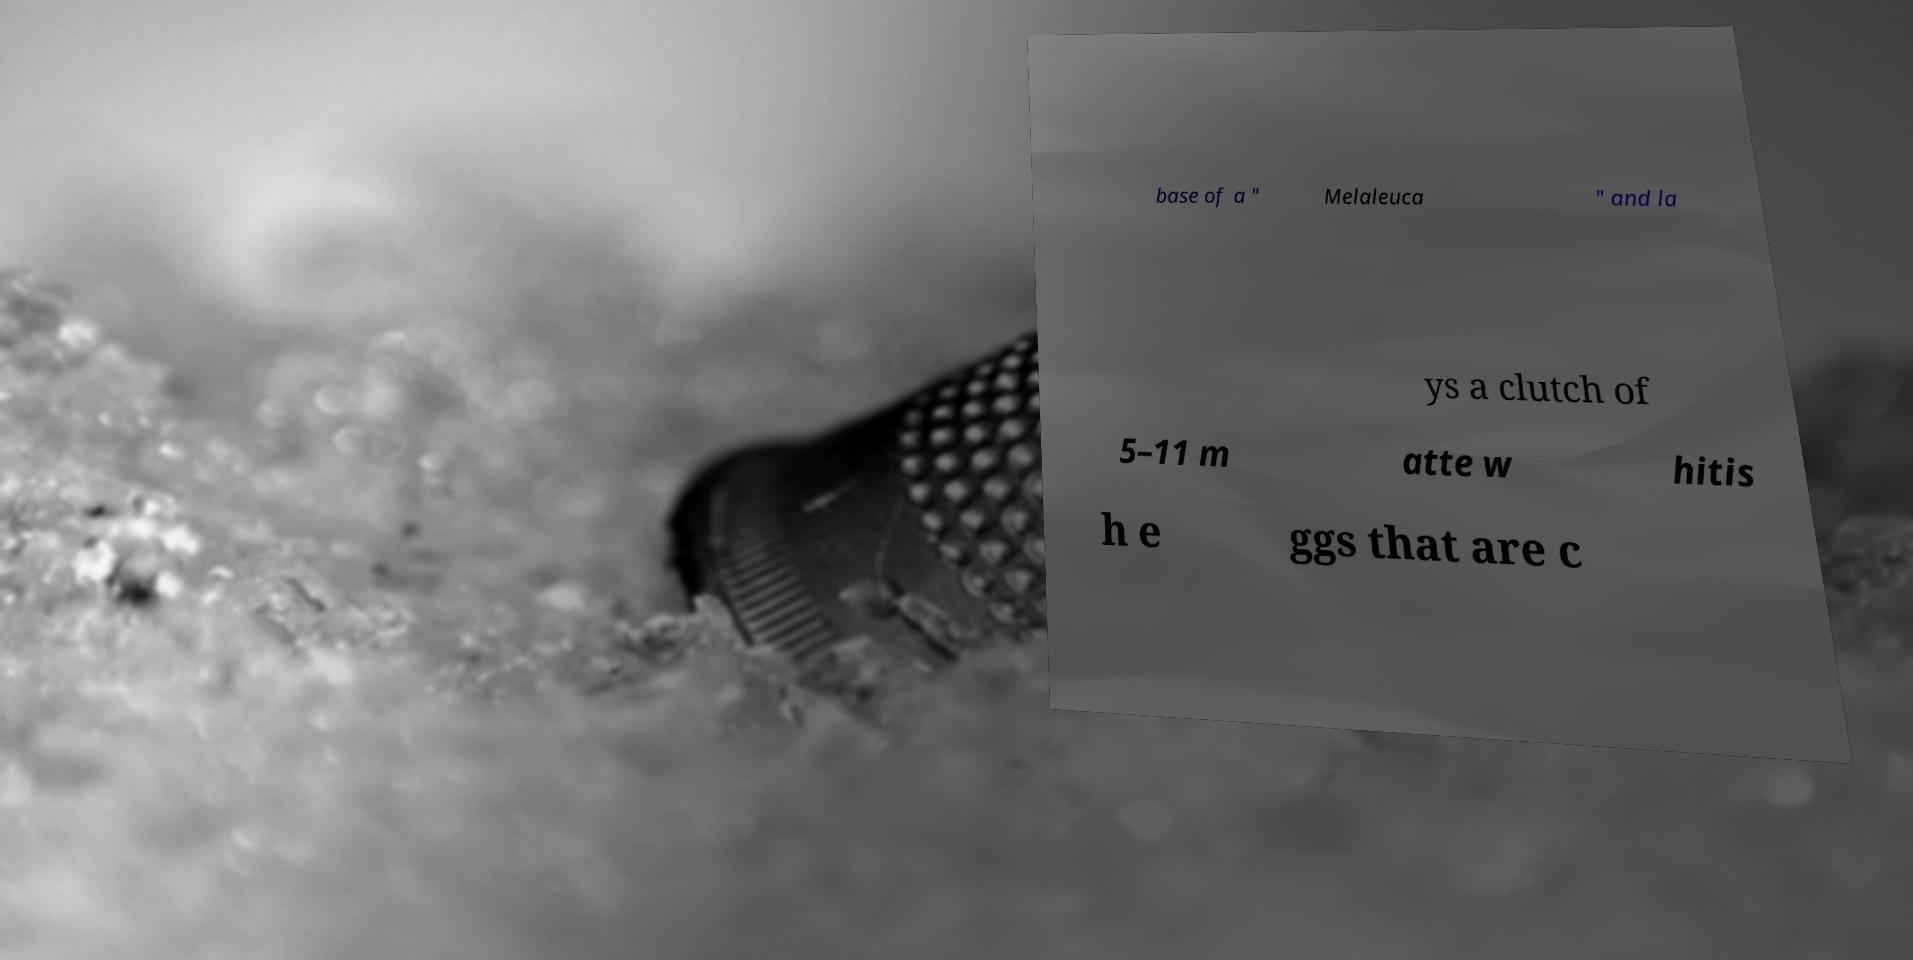For documentation purposes, I need the text within this image transcribed. Could you provide that? base of a " Melaleuca " and la ys a clutch of 5–11 m atte w hitis h e ggs that are c 